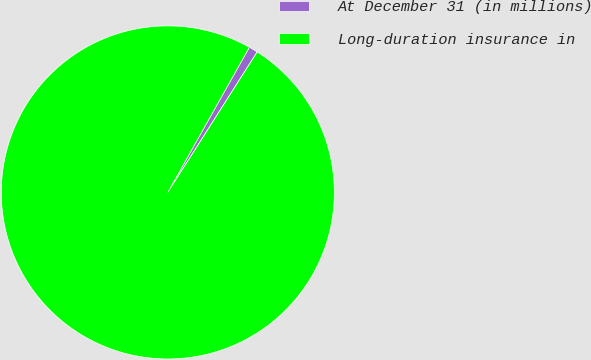<chart> <loc_0><loc_0><loc_500><loc_500><pie_chart><fcel>At December 31 (in millions)<fcel>Long-duration insurance in<nl><fcel>0.87%<fcel>99.13%<nl></chart> 